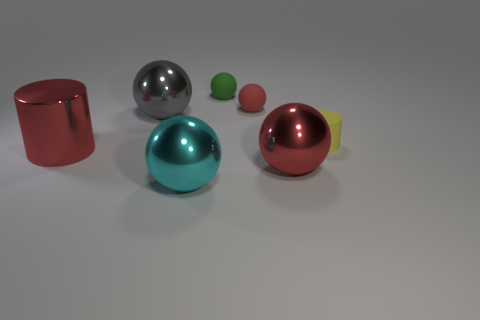Is the big sphere that is behind the red shiny cylinder made of the same material as the cyan sphere?
Give a very brief answer. Yes. How many other objects are the same material as the gray ball?
Your response must be concise. 3. What number of objects are small yellow cylinders that are in front of the green ball or shiny objects to the left of the cyan object?
Provide a short and direct response. 3. There is a shiny object that is to the right of the small green thing; does it have the same shape as the large red object that is left of the small green thing?
Offer a terse response. No. The gray object that is the same size as the red metal sphere is what shape?
Offer a very short reply. Sphere. How many shiny things are either tiny objects or tiny blue cylinders?
Your answer should be very brief. 0. Are the sphere that is in front of the red metal sphere and the large thing that is behind the tiny yellow object made of the same material?
Keep it short and to the point. Yes. What color is the cylinder that is made of the same material as the cyan thing?
Provide a succinct answer. Red. Are there more cyan metal objects to the left of the red metallic cylinder than cyan balls in front of the green rubber thing?
Offer a terse response. No. Are there any small red matte cubes?
Ensure brevity in your answer.  No. 